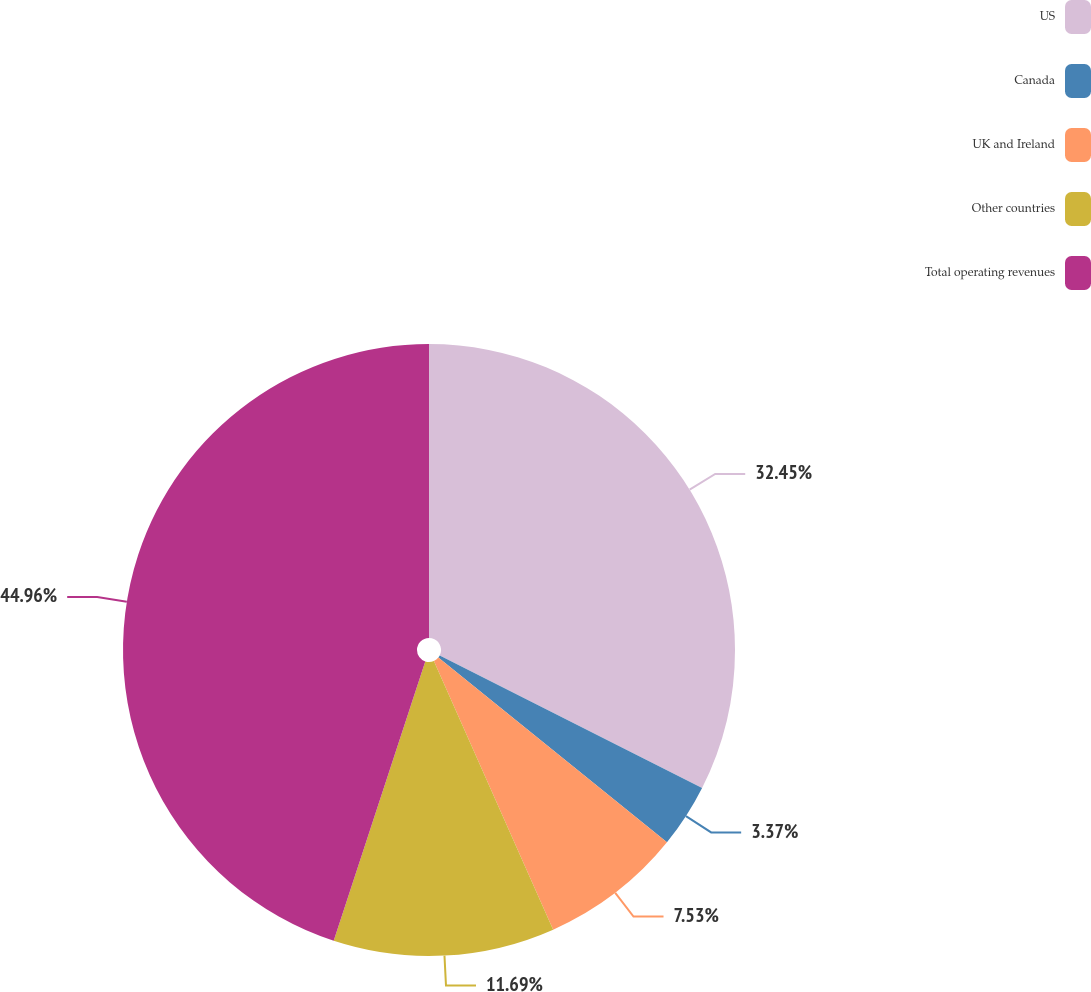Convert chart to OTSL. <chart><loc_0><loc_0><loc_500><loc_500><pie_chart><fcel>US<fcel>Canada<fcel>UK and Ireland<fcel>Other countries<fcel>Total operating revenues<nl><fcel>32.45%<fcel>3.37%<fcel>7.53%<fcel>11.69%<fcel>44.96%<nl></chart> 